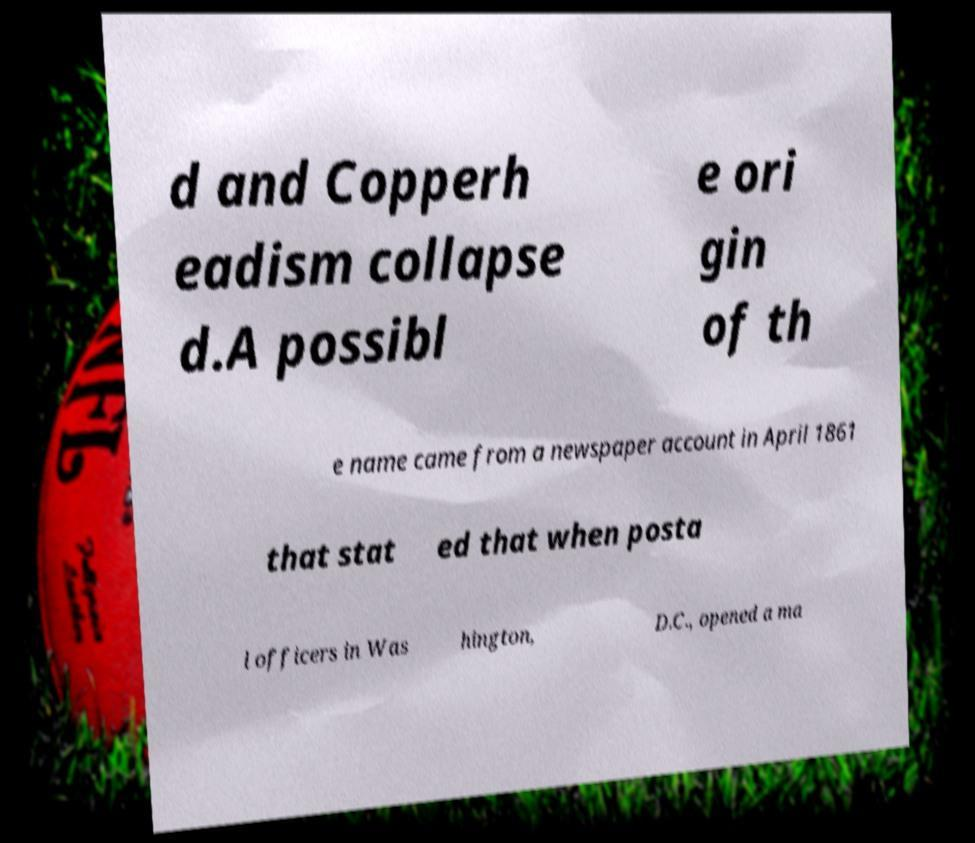Can you read and provide the text displayed in the image?This photo seems to have some interesting text. Can you extract and type it out for me? d and Copperh eadism collapse d.A possibl e ori gin of th e name came from a newspaper account in April 1861 that stat ed that when posta l officers in Was hington, D.C., opened a ma 